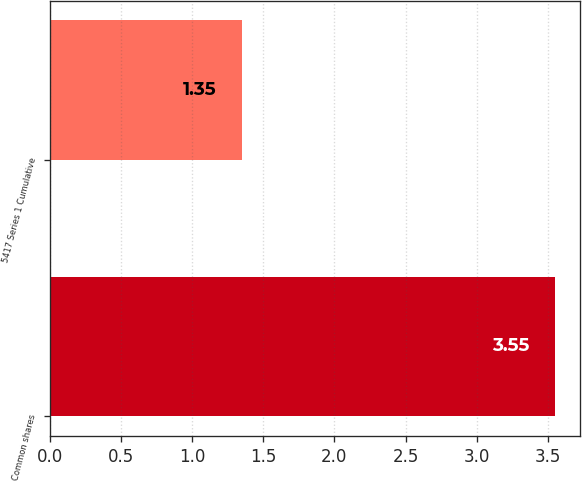Convert chart. <chart><loc_0><loc_0><loc_500><loc_500><bar_chart><fcel>Common shares<fcel>5417 Series 1 Cumulative<nl><fcel>3.55<fcel>1.35<nl></chart> 